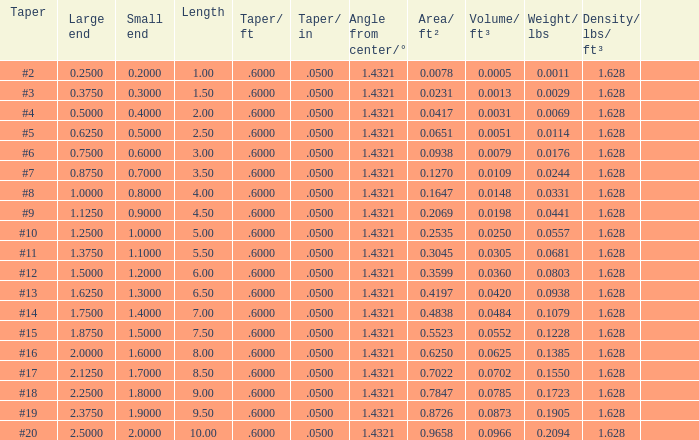Which Length has a Taper of #15, and a Large end larger than 1.875? None. 